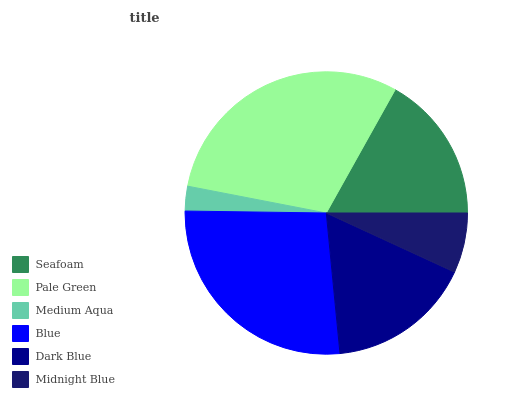Is Medium Aqua the minimum?
Answer yes or no. Yes. Is Pale Green the maximum?
Answer yes or no. Yes. Is Pale Green the minimum?
Answer yes or no. No. Is Medium Aqua the maximum?
Answer yes or no. No. Is Pale Green greater than Medium Aqua?
Answer yes or no. Yes. Is Medium Aqua less than Pale Green?
Answer yes or no. Yes. Is Medium Aqua greater than Pale Green?
Answer yes or no. No. Is Pale Green less than Medium Aqua?
Answer yes or no. No. Is Seafoam the high median?
Answer yes or no. Yes. Is Dark Blue the low median?
Answer yes or no. Yes. Is Pale Green the high median?
Answer yes or no. No. Is Medium Aqua the low median?
Answer yes or no. No. 